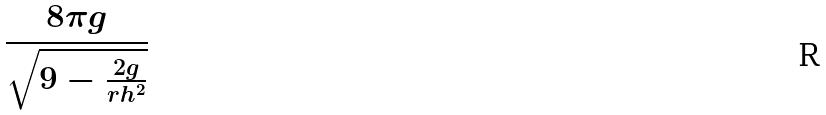Convert formula to latex. <formula><loc_0><loc_0><loc_500><loc_500>\frac { 8 \pi g } { \sqrt { 9 - \frac { 2 g } { r h ^ { 2 } } } }</formula> 